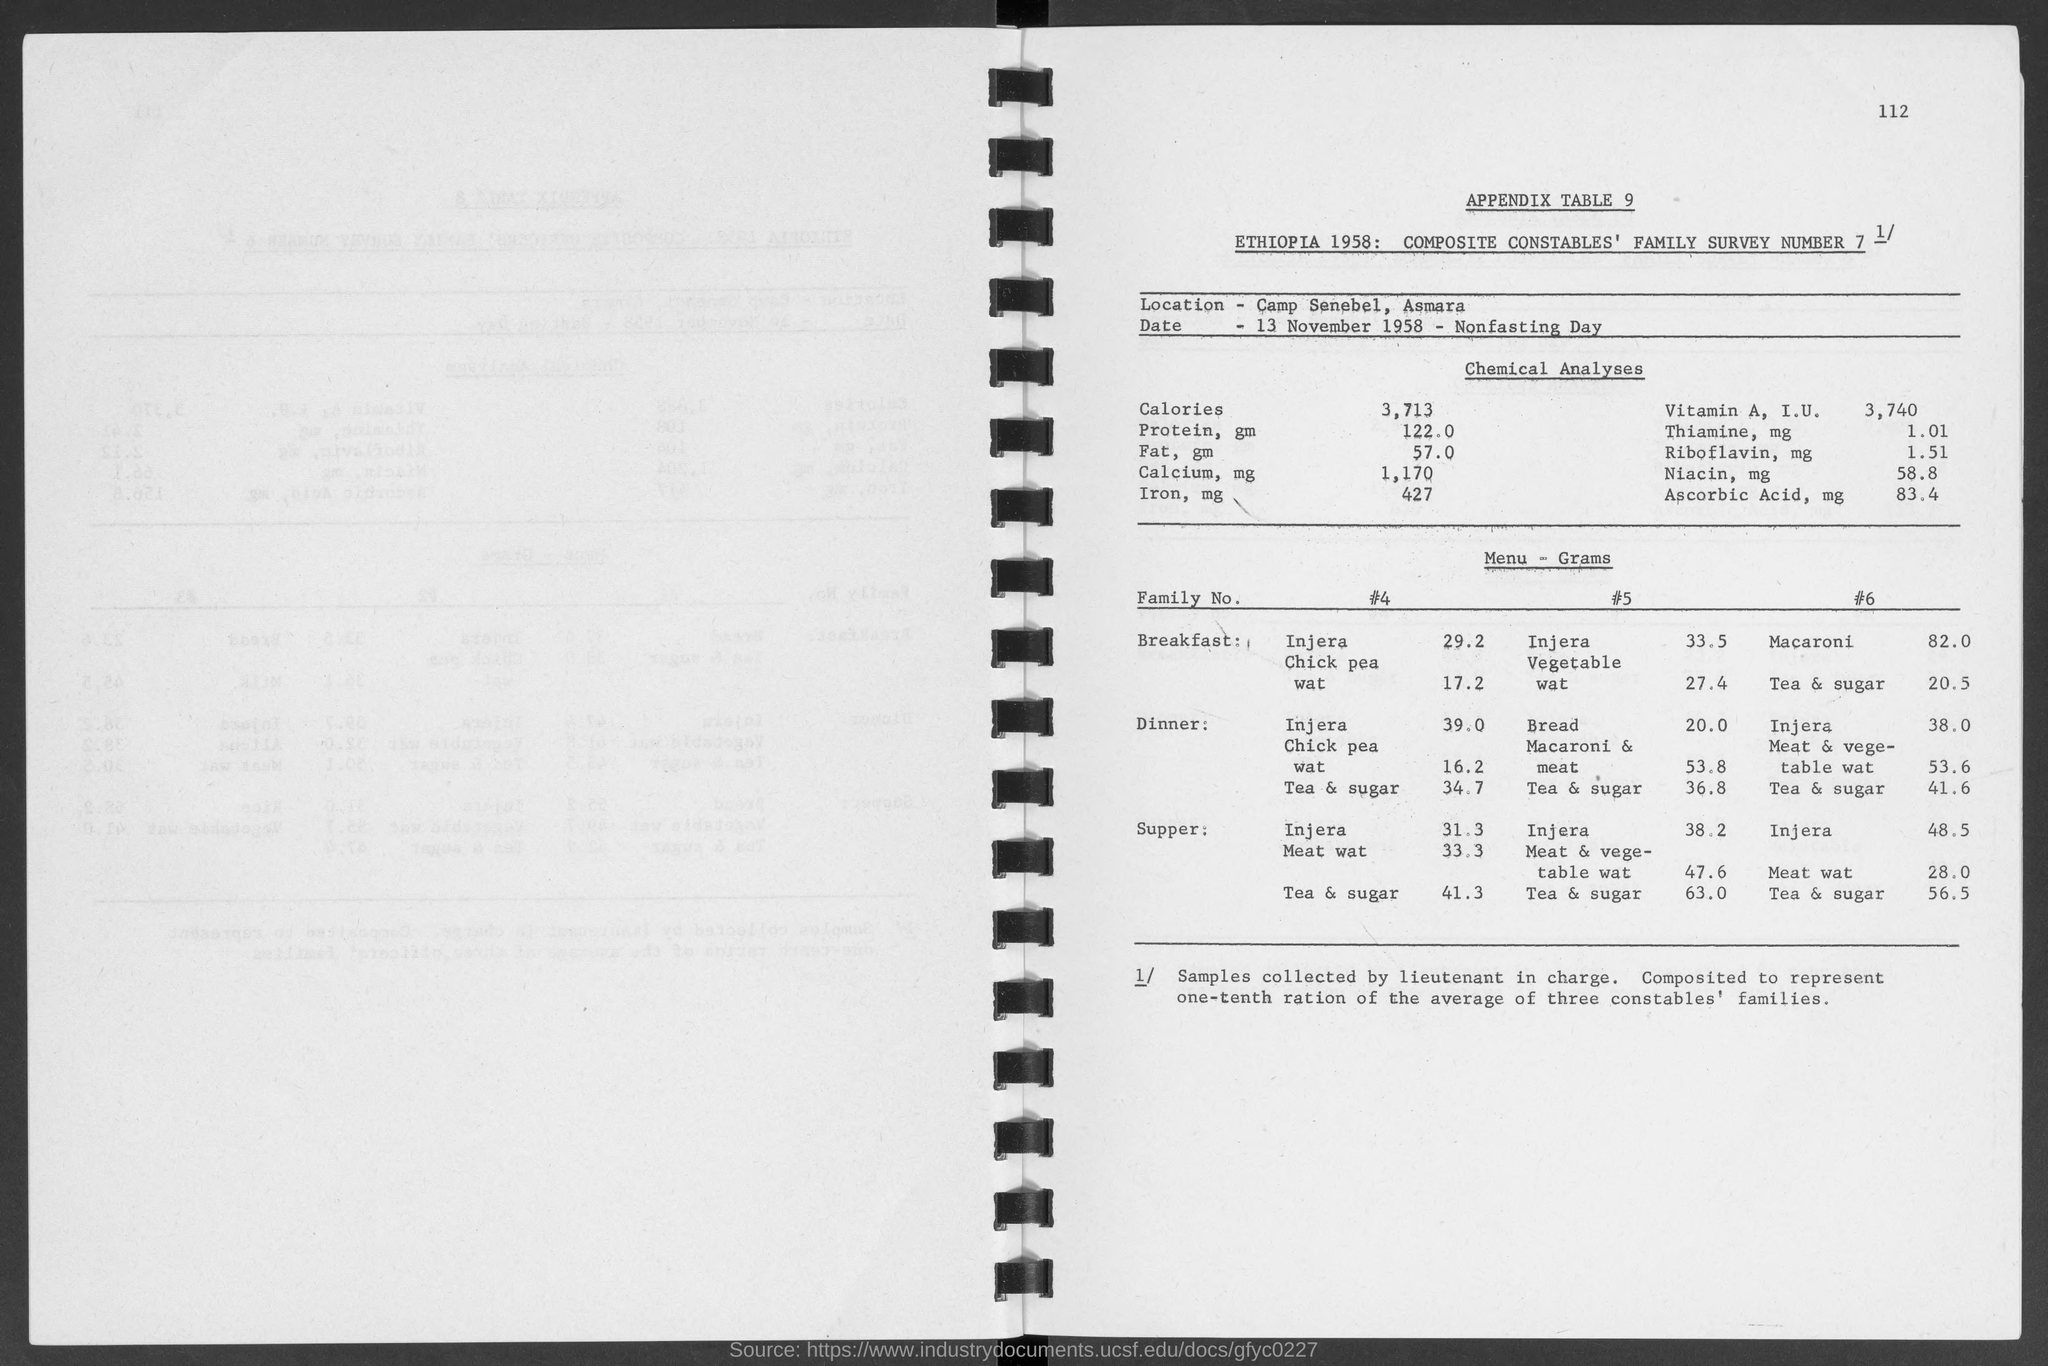What is the page number?
Provide a short and direct response. 112. What is the name of the location?
Keep it short and to the point. Camp Senebel. What is the date mentioned in the document?
Give a very brief answer. 13 NOVEMBER 1958. What is the amount of protein?
Offer a very short reply. 122.0. What is the amount of fat?
Your response must be concise. 57.0. What is the amount of injera in the breakfast of family number 4?
Make the answer very short. 29.2. What is the amount of meat wat in the supper of family number 4?
Your answer should be compact. 33.3. What is the amount of bread in the dinner of family number 5?
Provide a short and direct response. 20.0. 